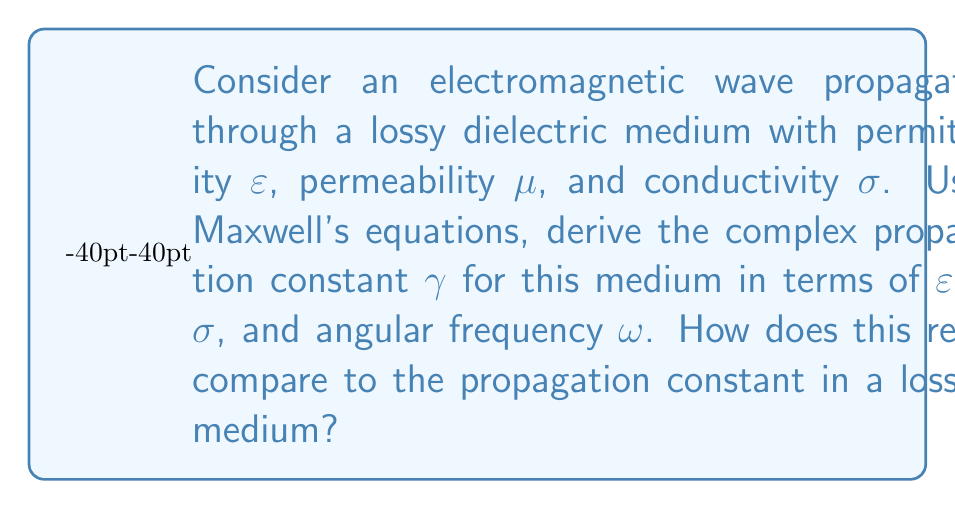Provide a solution to this math problem. Let's approach this step-by-step:

1) Start with Maxwell's equations in a lossy dielectric medium:

   $$\nabla \times \mathbf{E} = -\frac{\partial \mathbf{B}}{\partial t}$$
   $$\nabla \times \mathbf{H} = \mathbf{J} + \frac{\partial \mathbf{D}}{\partial t}$$

2) For a lossy dielectric, we have:
   
   $$\mathbf{D} = \varepsilon \mathbf{E}$$
   $$\mathbf{B} = \mu \mathbf{H}$$
   $$\mathbf{J} = \sigma \mathbf{E}$$

3) Assume time-harmonic fields with $e^{j\omega t}$ dependence:

   $$\mathbf{E}(\mathbf{r},t) = \mathbf{E}(\mathbf{r})e^{j\omega t}$$
   $$\mathbf{H}(\mathbf{r},t) = \mathbf{H}(\mathbf{r})e^{j\omega t}$$

4) Substitute these into Maxwell's curl equations:

   $$\nabla \times \mathbf{E} = -j\omega\mu\mathbf{H}$$
   $$\nabla \times \mathbf{H} = (\sigma + j\omega\varepsilon)\mathbf{E}$$

5) Take the curl of the first equation:

   $$\nabla \times (\nabla \times \mathbf{E}) = -j\omega\mu(\nabla \times \mathbf{H})$$

6) Use the vector identity $\nabla \times (\nabla \times \mathbf{E}) = \nabla(\nabla \cdot \mathbf{E}) - \nabla^2\mathbf{E}$. In a source-free region, $\nabla \cdot \mathbf{E} = 0$, so:

   $$-\nabla^2\mathbf{E} = -j\omega\mu(\sigma + j\omega\varepsilon)\mathbf{E}$$

7) This can be written as:

   $$\nabla^2\mathbf{E} + \omega^2\mu\varepsilon(1-j\frac{\sigma}{\omega\varepsilon})\mathbf{E} = 0$$

8) The complex propagation constant $\gamma$ is defined such that $\nabla^2\mathbf{E} = \gamma^2\mathbf{E}$. Therefore:

   $$\gamma^2 = -\omega^2\mu\varepsilon(1-j\frac{\sigma}{\omega\varepsilon})$$

9) Taking the square root:

   $$\gamma = \pm j\omega\sqrt{\mu\varepsilon}\sqrt{1-j\frac{\sigma}{\omega\varepsilon}}$$

10) In a lossless medium, $\sigma = 0$, so the propagation constant becomes:

    $$\gamma_{lossless} = \pm j\omega\sqrt{\mu\varepsilon}$$

The complex propagation constant in a lossy medium introduces attenuation, unlike in a lossless medium where the wave propagates without loss.
Answer: $\gamma = \pm j\omega\sqrt{\mu\varepsilon}\sqrt{1-j\frac{\sigma}{\omega\varepsilon}}$ 